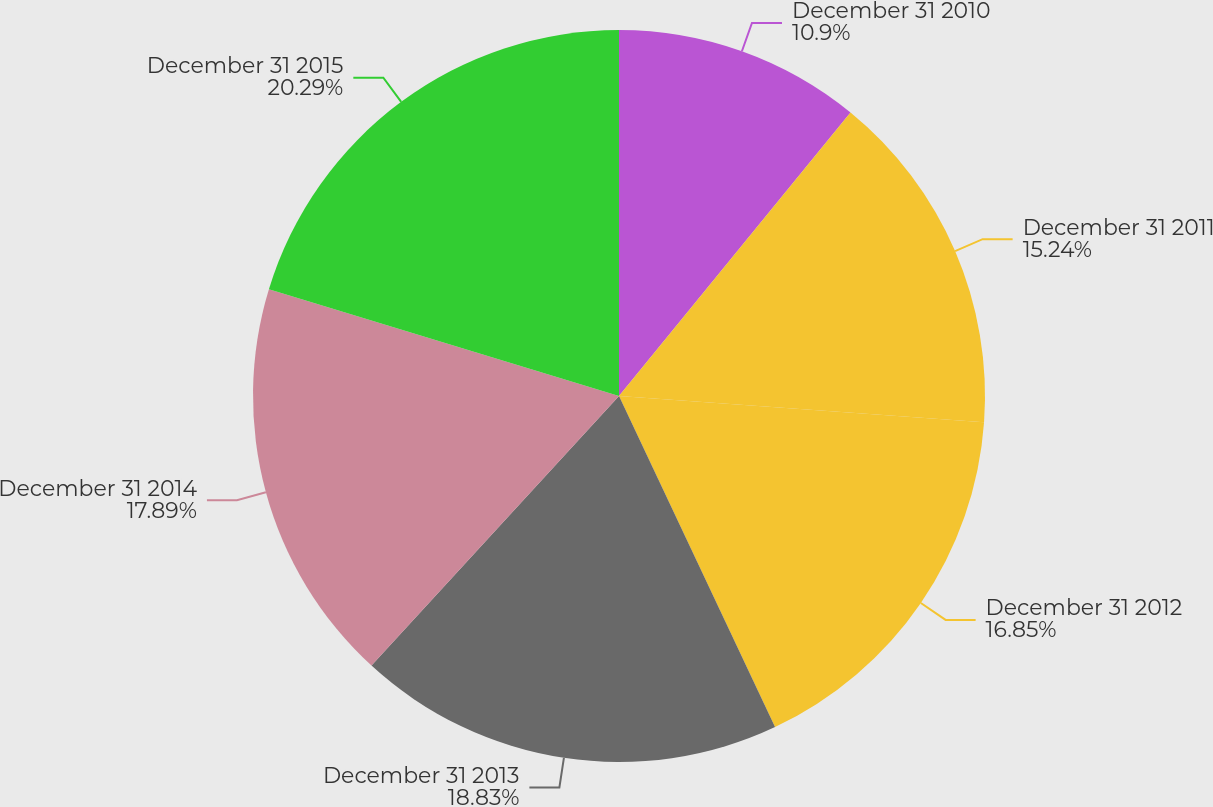Convert chart. <chart><loc_0><loc_0><loc_500><loc_500><pie_chart><fcel>December 31 2010<fcel>December 31 2011<fcel>December 31 2012<fcel>December 31 2013<fcel>December 31 2014<fcel>December 31 2015<nl><fcel>10.9%<fcel>15.24%<fcel>16.85%<fcel>18.83%<fcel>17.89%<fcel>20.29%<nl></chart> 